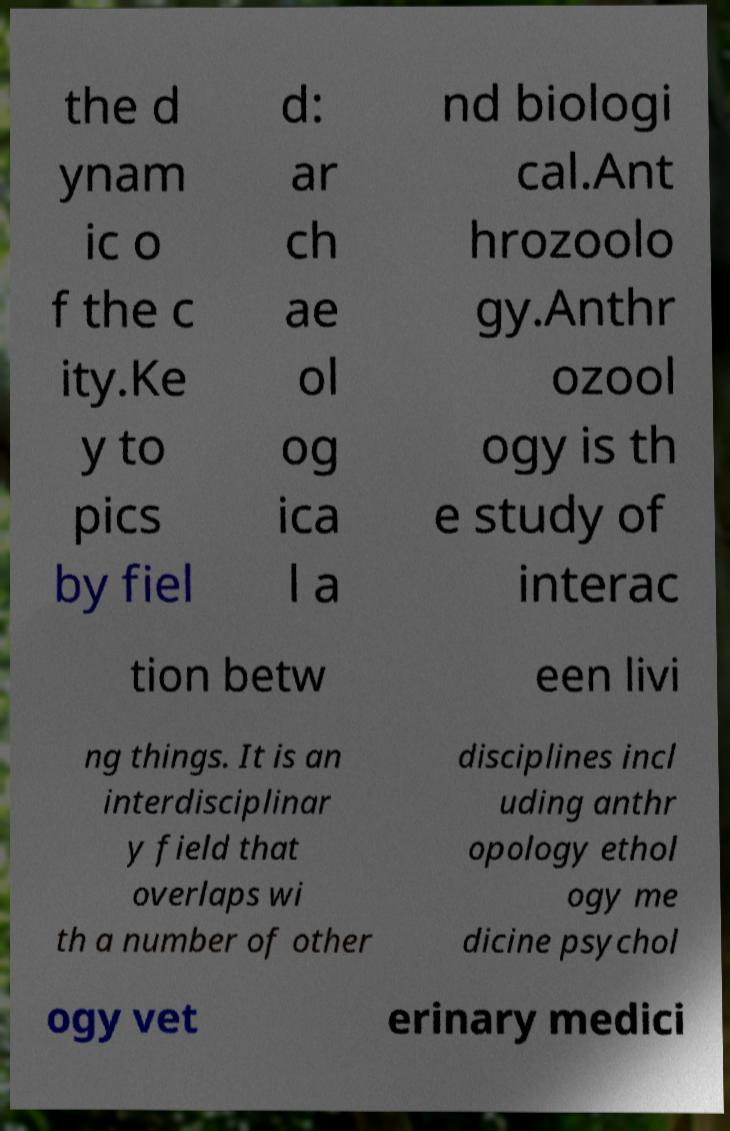Could you assist in decoding the text presented in this image and type it out clearly? the d ynam ic o f the c ity.Ke y to pics by fiel d: ar ch ae ol og ica l a nd biologi cal.Ant hrozoolo gy.Anthr ozool ogy is th e study of interac tion betw een livi ng things. It is an interdisciplinar y field that overlaps wi th a number of other disciplines incl uding anthr opology ethol ogy me dicine psychol ogy vet erinary medici 